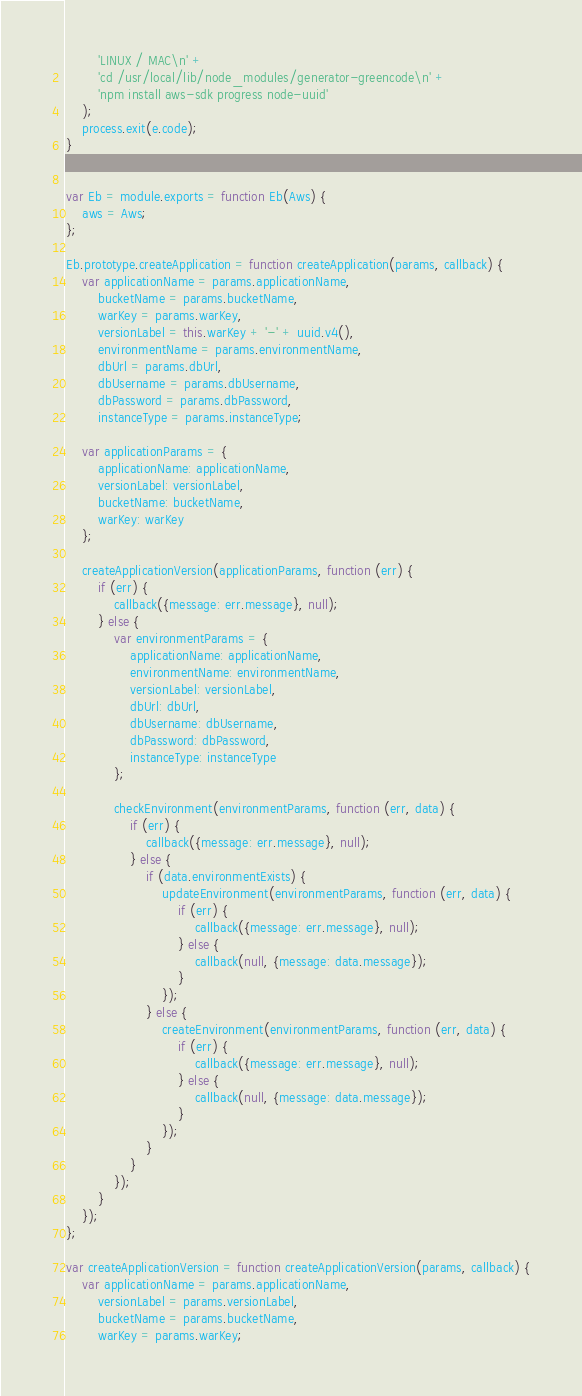<code> <loc_0><loc_0><loc_500><loc_500><_JavaScript_>        'LINUX / MAC\n' +
        'cd /usr/local/lib/node_modules/generator-greencode\n' +
        'npm install aws-sdk progress node-uuid'
    );
    process.exit(e.code);
}


var Eb = module.exports = function Eb(Aws) {
    aws = Aws;
};

Eb.prototype.createApplication = function createApplication(params, callback) {
    var applicationName = params.applicationName,
        bucketName = params.bucketName,
        warKey = params.warKey,
        versionLabel = this.warKey + '-' + uuid.v4(),
        environmentName = params.environmentName,
        dbUrl = params.dbUrl,
        dbUsername = params.dbUsername,
        dbPassword = params.dbPassword,
        instanceType = params.instanceType;

    var applicationParams = {
        applicationName: applicationName,
        versionLabel: versionLabel,
        bucketName: bucketName,
        warKey: warKey
    };

    createApplicationVersion(applicationParams, function (err) {
        if (err) {
            callback({message: err.message}, null);
        } else {
            var environmentParams = {
                applicationName: applicationName,
                environmentName: environmentName,
                versionLabel: versionLabel,
                dbUrl: dbUrl,
                dbUsername: dbUsername,
                dbPassword: dbPassword,
                instanceType: instanceType
            };

            checkEnvironment(environmentParams, function (err, data) {
                if (err) {
                    callback({message: err.message}, null);
                } else {
                    if (data.environmentExists) {
                        updateEnvironment(environmentParams, function (err, data) {
                            if (err) {
                                callback({message: err.message}, null);
                            } else {
                                callback(null, {message: data.message});
                            }
                        });
                    } else {
                        createEnvironment(environmentParams, function (err, data) {
                            if (err) {
                                callback({message: err.message}, null);
                            } else {
                                callback(null, {message: data.message});
                            }
                        });
                    }
                }
            });
        }
    });
};

var createApplicationVersion = function createApplicationVersion(params, callback) {
    var applicationName = params.applicationName,
        versionLabel = params.versionLabel,
        bucketName = params.bucketName,
        warKey = params.warKey;
</code> 